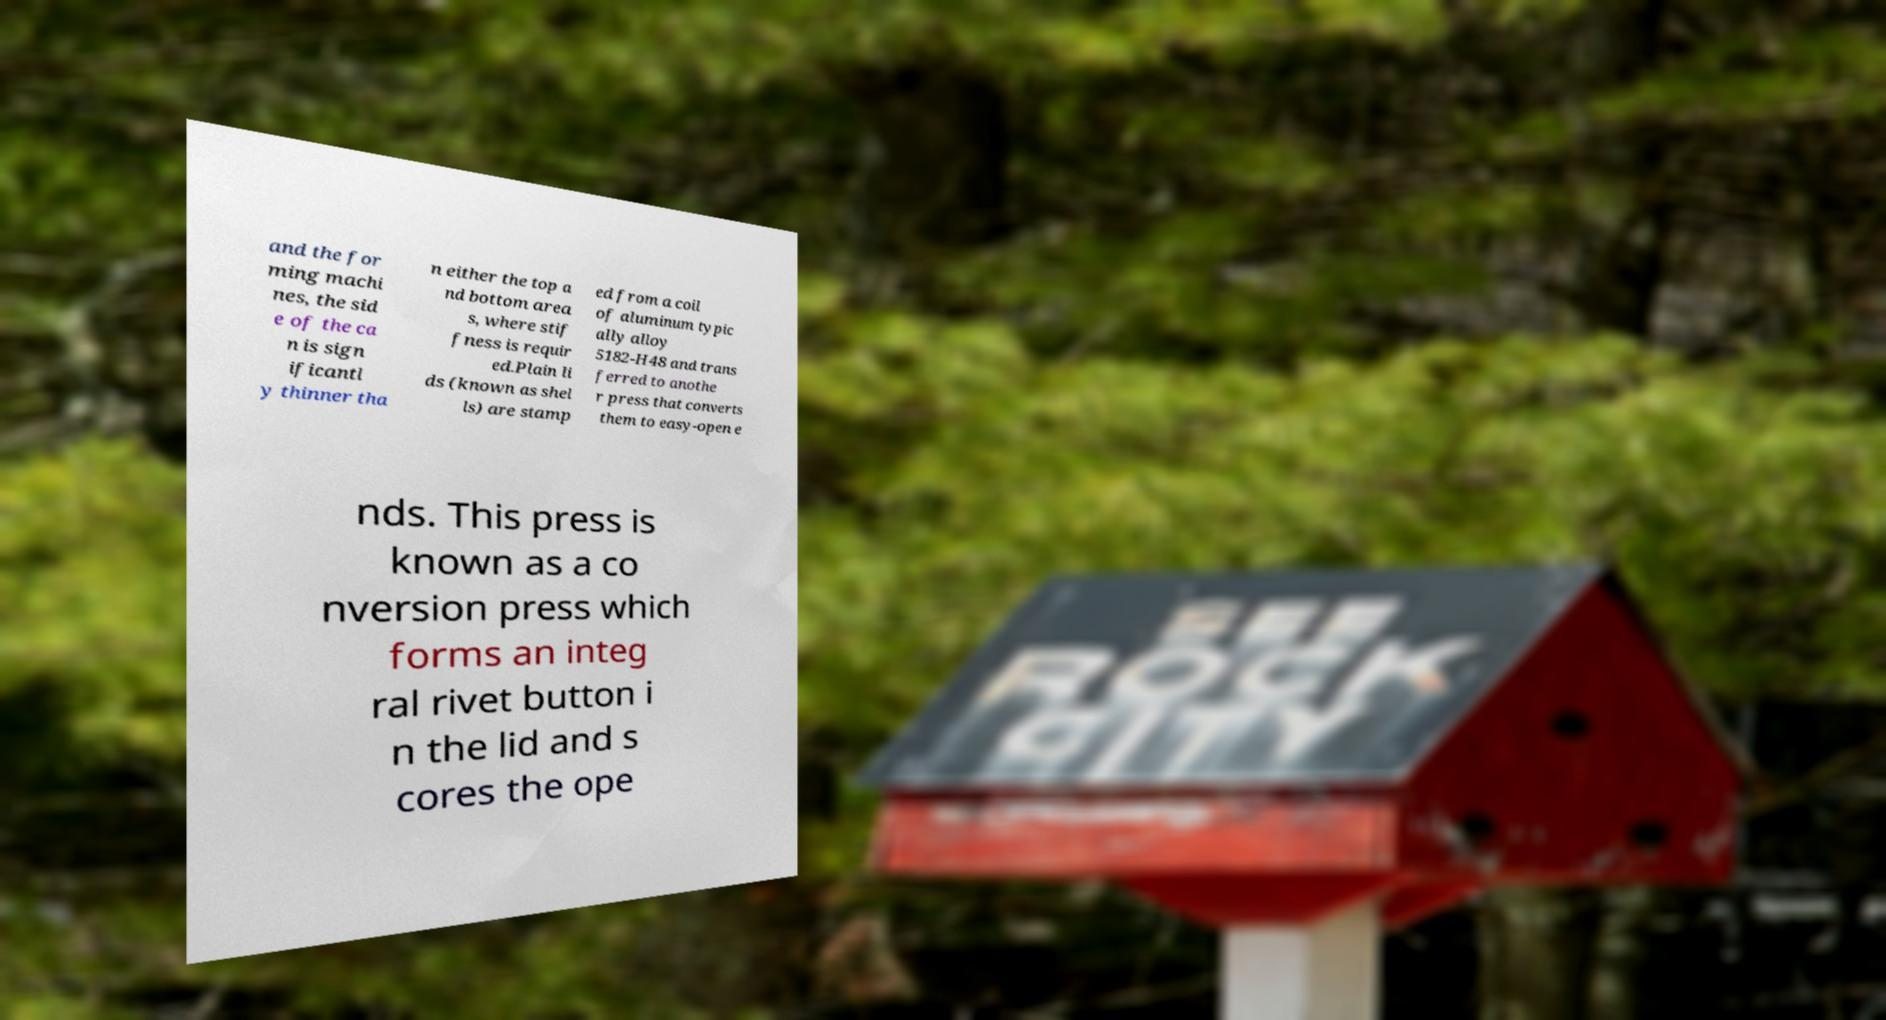Could you assist in decoding the text presented in this image and type it out clearly? and the for ming machi nes, the sid e of the ca n is sign ificantl y thinner tha n either the top a nd bottom area s, where stif fness is requir ed.Plain li ds (known as shel ls) are stamp ed from a coil of aluminum typic ally alloy 5182-H48 and trans ferred to anothe r press that converts them to easy-open e nds. This press is known as a co nversion press which forms an integ ral rivet button i n the lid and s cores the ope 